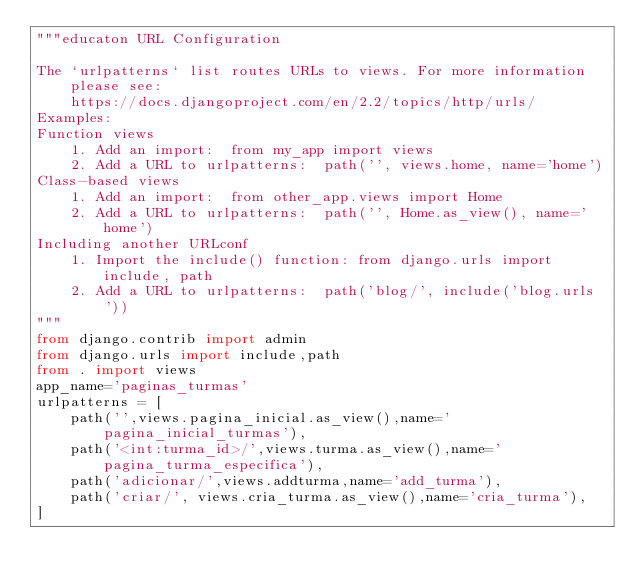Convert code to text. <code><loc_0><loc_0><loc_500><loc_500><_Python_>"""educaton URL Configuration

The `urlpatterns` list routes URLs to views. For more information please see:
    https://docs.djangoproject.com/en/2.2/topics/http/urls/
Examples:
Function views
    1. Add an import:  from my_app import views
    2. Add a URL to urlpatterns:  path('', views.home, name='home')
Class-based views
    1. Add an import:  from other_app.views import Home
    2. Add a URL to urlpatterns:  path('', Home.as_view(), name='home')
Including another URLconf
    1. Import the include() function: from django.urls import include, path
    2. Add a URL to urlpatterns:  path('blog/', include('blog.urls'))
"""
from django.contrib import admin
from django.urls import include,path
from . import views
app_name='paginas_turmas'
urlpatterns = [
    path('',views.pagina_inicial.as_view(),name='pagina_inicial_turmas'),
    path('<int:turma_id>/',views.turma.as_view(),name='pagina_turma_especifica'),
    path('adicionar/',views.addturma,name='add_turma'),
    path('criar/', views.cria_turma.as_view(),name='cria_turma'),
]
</code> 